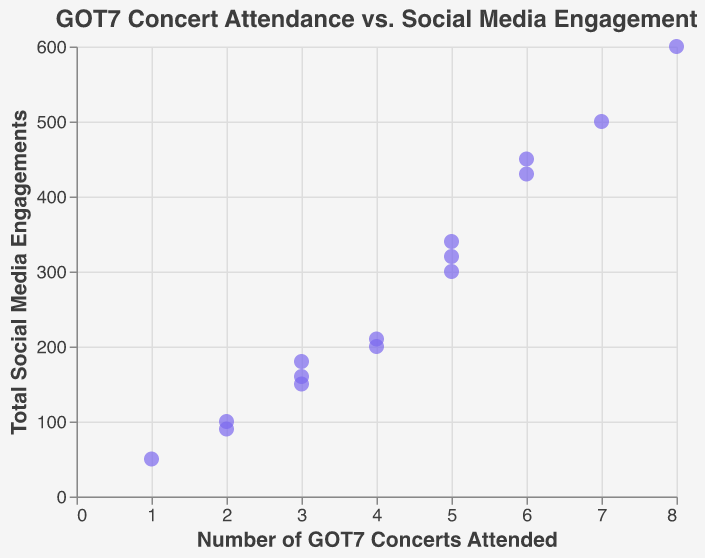How many data points are there in the figure? Count each point plotted on the scatter plot. Each point represents an individual.
Answer: 15 What is the title of the scatter plot? The title is usually displayed at the top of the plot and explains what the graph is about.
Answer: GOT7 Concert Attendance vs. Social Media Engagement Which username has attended the most concerts? Find the data point with the highest value on the x-axis (Number of GOT7 Concerts Attended).
Answer: ticket_collector What is the total social media engagement for 'live_music_luke'? Hover over the relevant data point or refer to the tooltip.
Answer: 200 What is the range of social media engagements shown in the plot? Find the minimum and maximum values on the y-axis (Total Social Media Engagements).
Answer: 50 to 600 Which user has the highest social media engagement? Find the data point with the highest value on the y-axis (Total Social Media Engagements).
Answer: ticket_collector What is the average number of concerts attended by the users? Add up all the values on the x-axis (Number of GOT7 Concerts Attended) and divide by the number of data points (15).
Answer: 4.4 Is there a general trend between concert attendance and social media engagement? Observe the distribution of points and whether they seem to form an upward or downward pattern.
Answer: Yes, generally positive Which users attended exactly 3 concerts? Look for data points where the x-axis value is 3 and check the respective usernames in the tooltip.
Answer: music_fanatic23, rhythm_chaser, symphony_sarah Who has higher social media engagement, 'dance_fever101' or 'fandom_forever'? Compare the y-axis values (Total Social Media Engagements) for 'dance_fever101' and 'fandom_forever'.
Answer: fandom_forever 